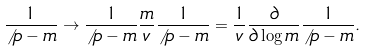<formula> <loc_0><loc_0><loc_500><loc_500>\frac { 1 } { \not \, p - m } \to \frac { 1 } { \not \, p - m } \frac { m } { v } \frac { 1 } { \not \, p - m } = \frac { 1 } { v } \frac { \partial } { \partial \log m } \frac { 1 } { \not \, p - m } .</formula> 